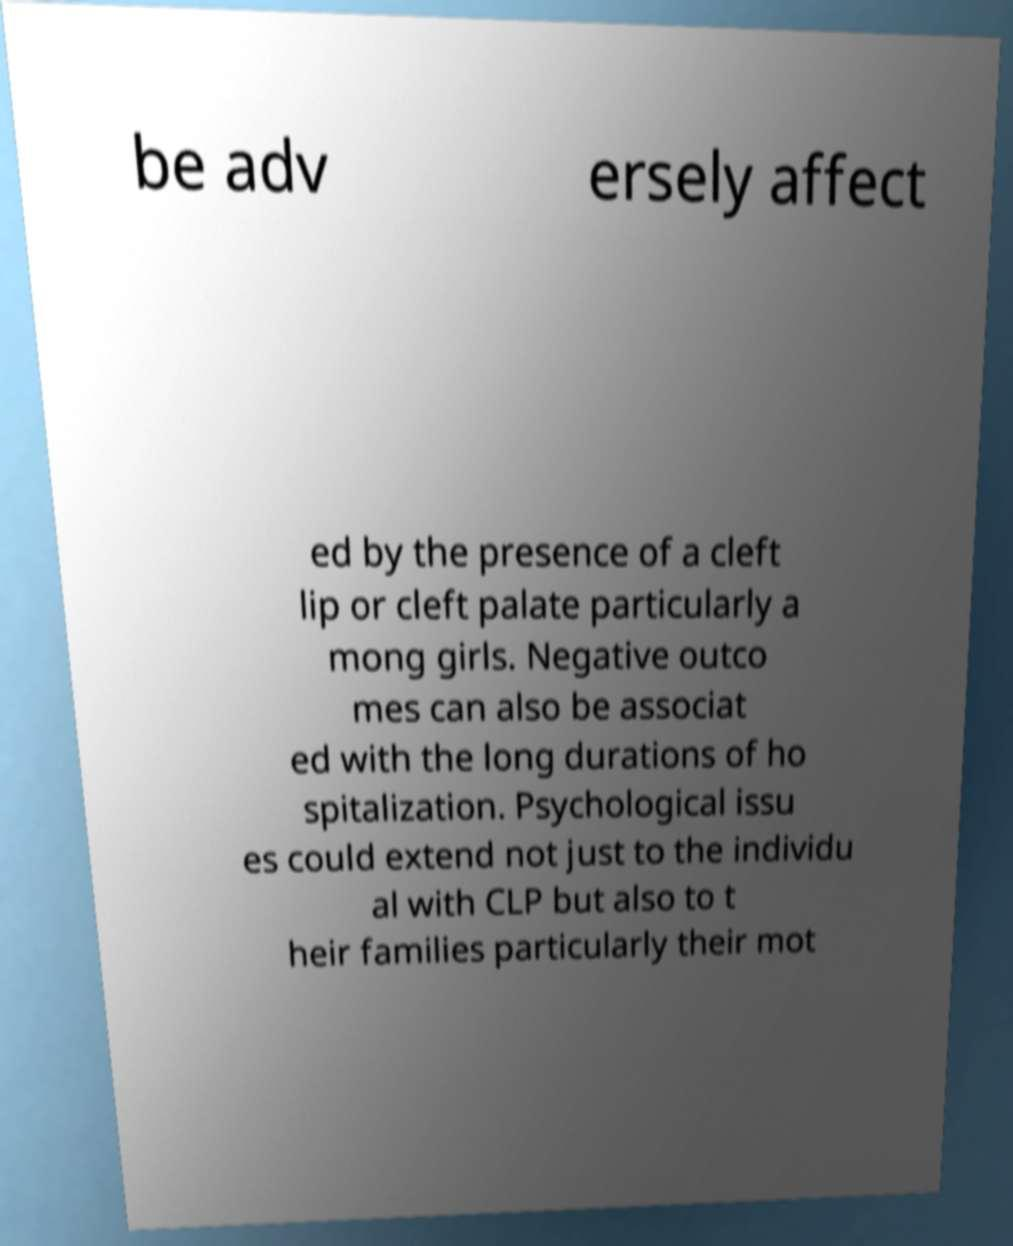Could you assist in decoding the text presented in this image and type it out clearly? be adv ersely affect ed by the presence of a cleft lip or cleft palate particularly a mong girls. Negative outco mes can also be associat ed with the long durations of ho spitalization. Psychological issu es could extend not just to the individu al with CLP but also to t heir families particularly their mot 